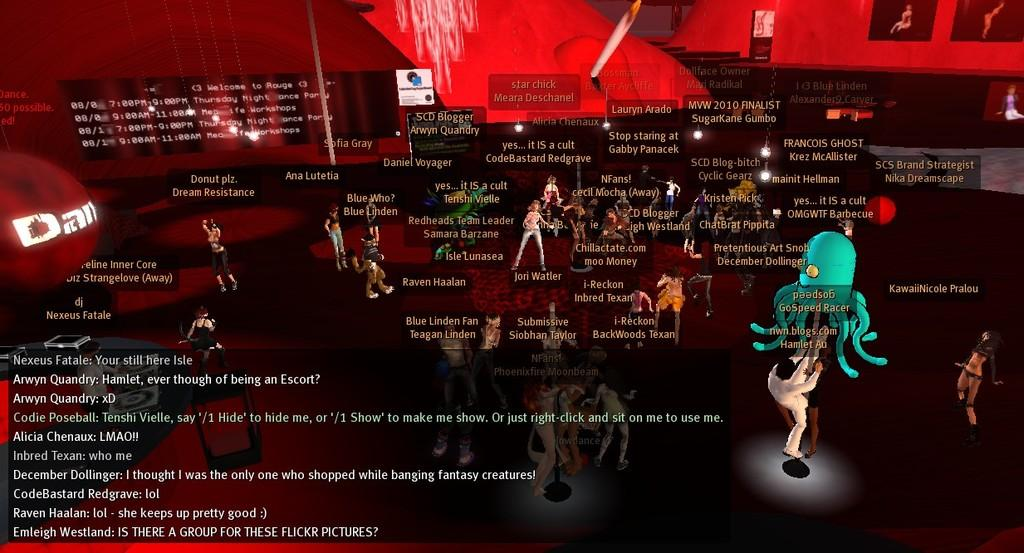What is the main subject of the image? The main subject of the image is an animated screen. What can be seen on the screen? There are animated pictures on the screen. Is there any text visible on the screen? Yes, there is text visible on the screen. What type of toothpaste is being advertised on the screen? There is no toothpaste present in the image; it features an animated screen with animated pictures and text. How many twigs are visible on the screen? There are no twigs visible on the screen; it features animated pictures and text. 